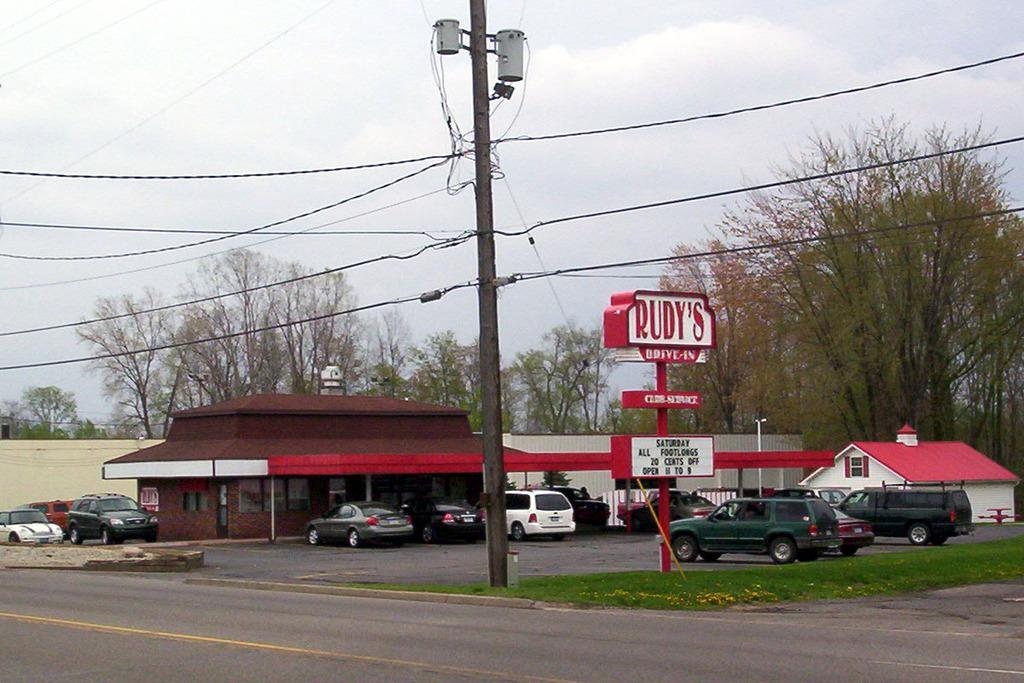What type of vegetation can be seen in the image? There are trees in the image. What type of infrastructure is present in the image? There is a current pole in the image. What type of transportation is visible in the image? There are cars in the image. What type of ground cover is present in the image? There is grass in the image. What type of building is visible in the image? There is a house in the image. What is visible in the background of the image? The sky is visible in the image. What type of corn is growing on the current pole in the image? There is no corn present in the image, and the current pole is not a place where corn would grow. What is the weight of the rock that is being lifted by the house in the image? There is no rock present in the image, and the house is not lifting anything. 